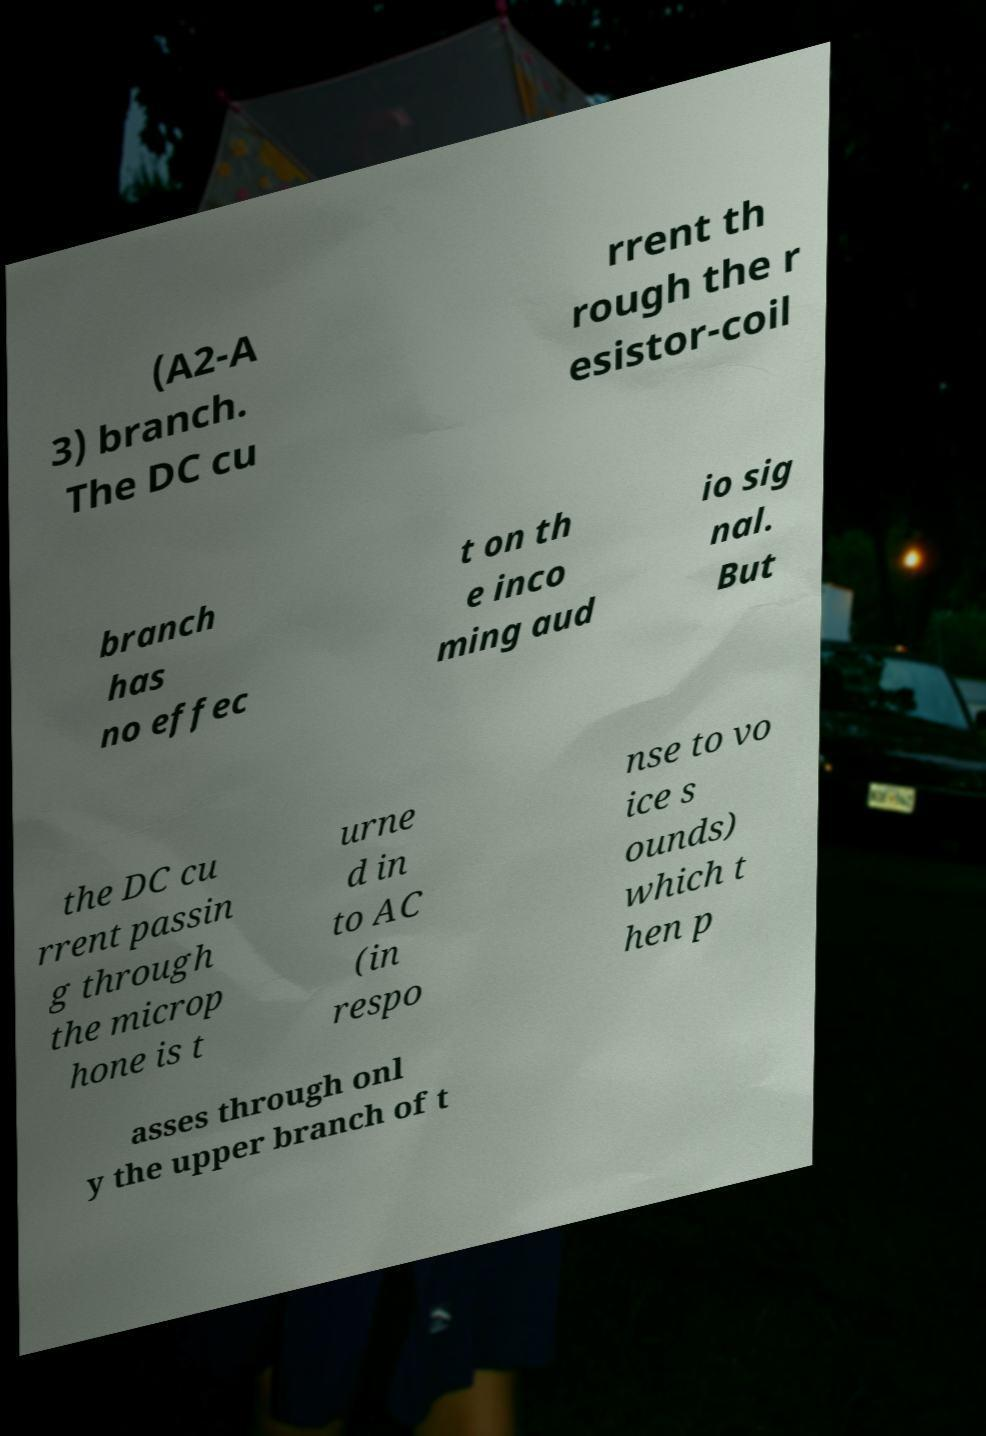For documentation purposes, I need the text within this image transcribed. Could you provide that? (A2-A 3) branch. The DC cu rrent th rough the r esistor-coil branch has no effec t on th e inco ming aud io sig nal. But the DC cu rrent passin g through the microp hone is t urne d in to AC (in respo nse to vo ice s ounds) which t hen p asses through onl y the upper branch of t 